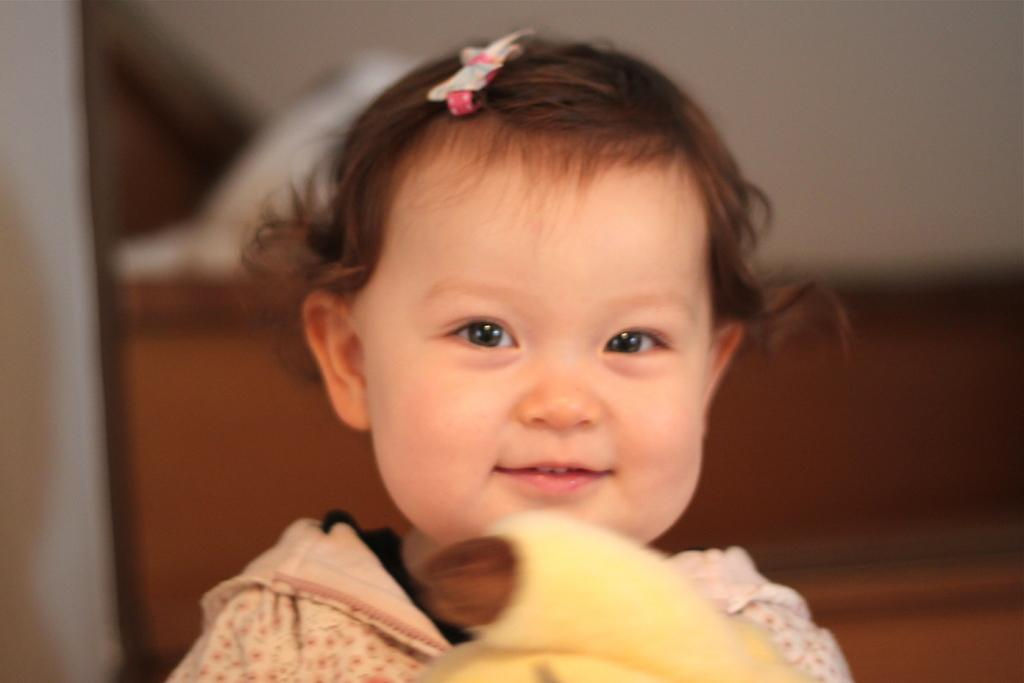What is the main subject of the image? There is a baby in the image. What is the baby doing in the image? The baby is smiling and holding a toy. Can you describe the background of the image? The background of the image is blurred. How many apples can be seen in the image? There are no apples present in the image. What type of volleyball is the baby playing with in the image? There is no volleyball present in the image; the baby is holding a toy. 